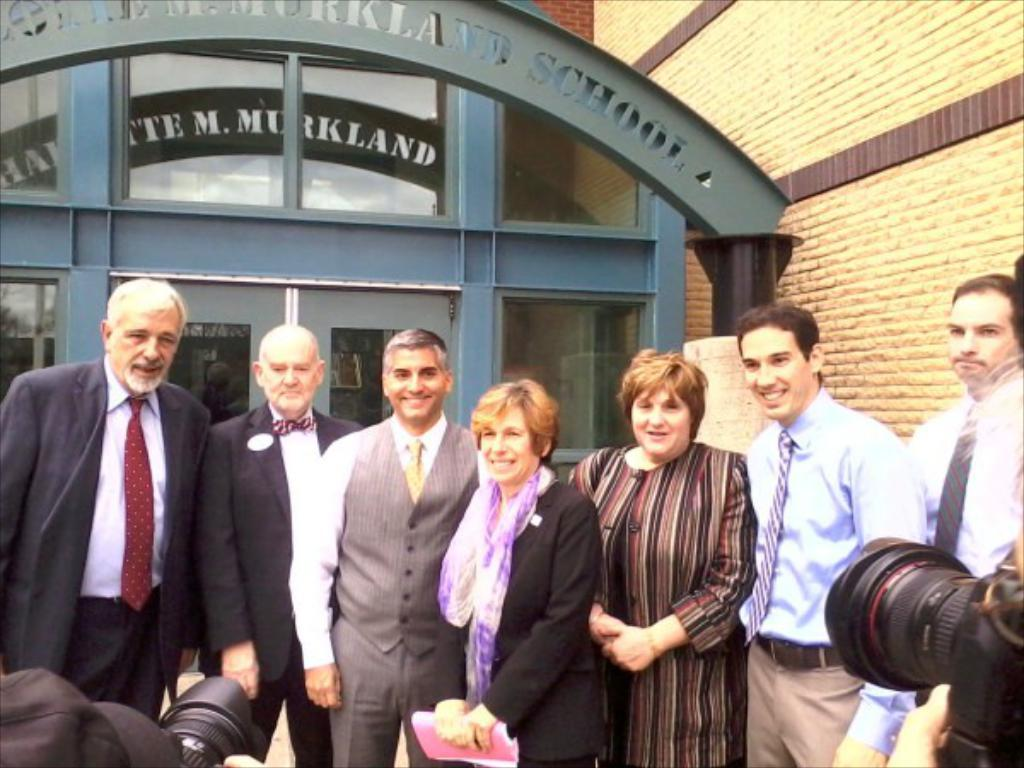What can be seen in the image involving people? There are people standing in the image. What objects are located at the bottom of the image? There are cameras at the bottom of the image. What type of structure is visible in the background of the image? There is an arch in the background of the image. What else can be seen in the background of the image? There are buildings visible in the background of the image. Can you tell me how many goldfish are swimming in the image? There are no goldfish present in the image. What type of channel is visible in the image? There is no channel visible in the image. 